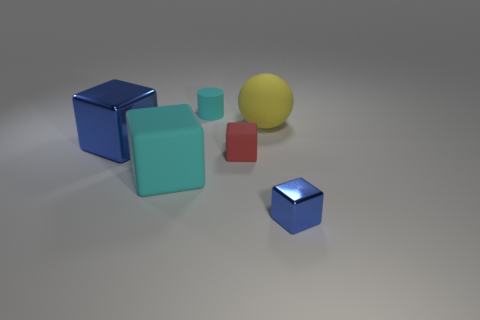Do the objects form any pattern or alignment? The objects are arranged in no specific pattern; they are placed seemingly at random across the surface. The varying sizes and colors of the objects, along with the lack of an identifiable pattern, create an abstract and open composition. 